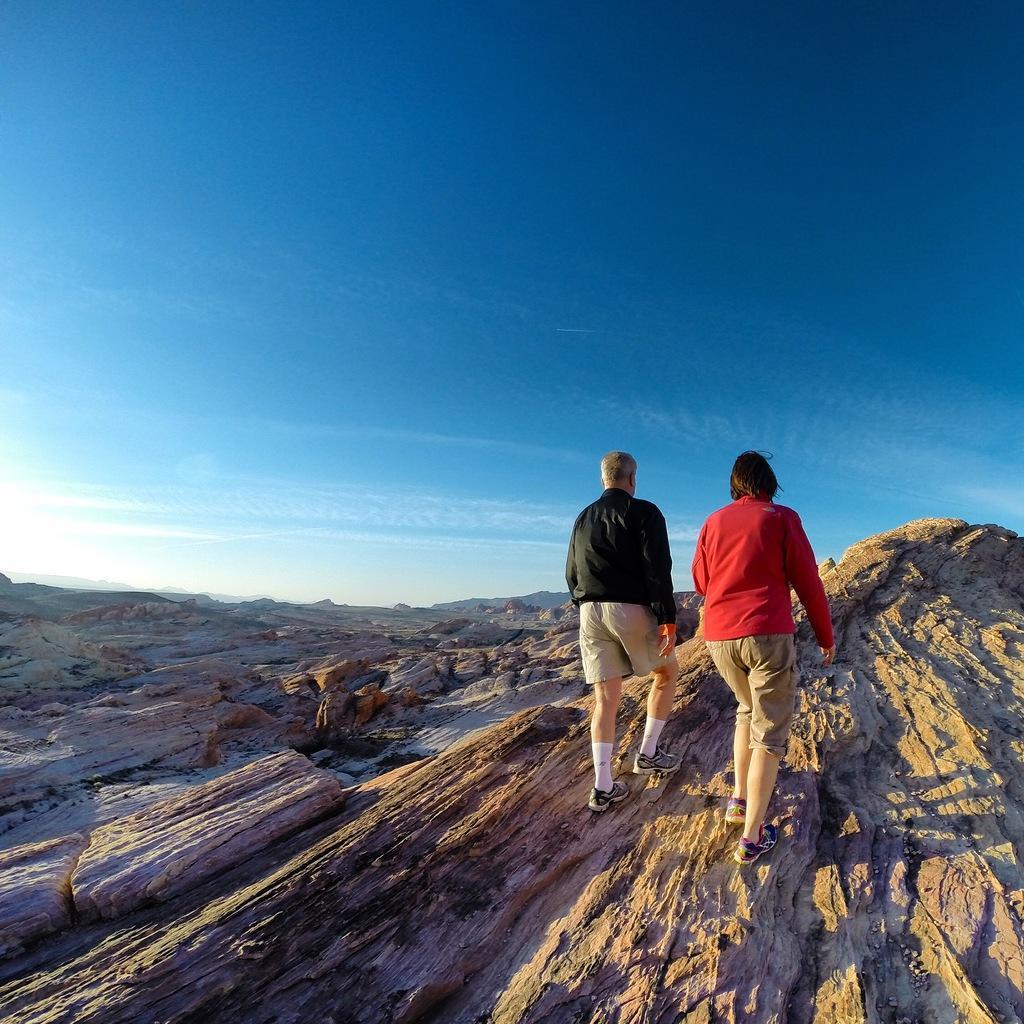Please provide a concise description of this image. In the image in the center, we can see two people are walking. In the background, we can see the sky, clouds and hills. 